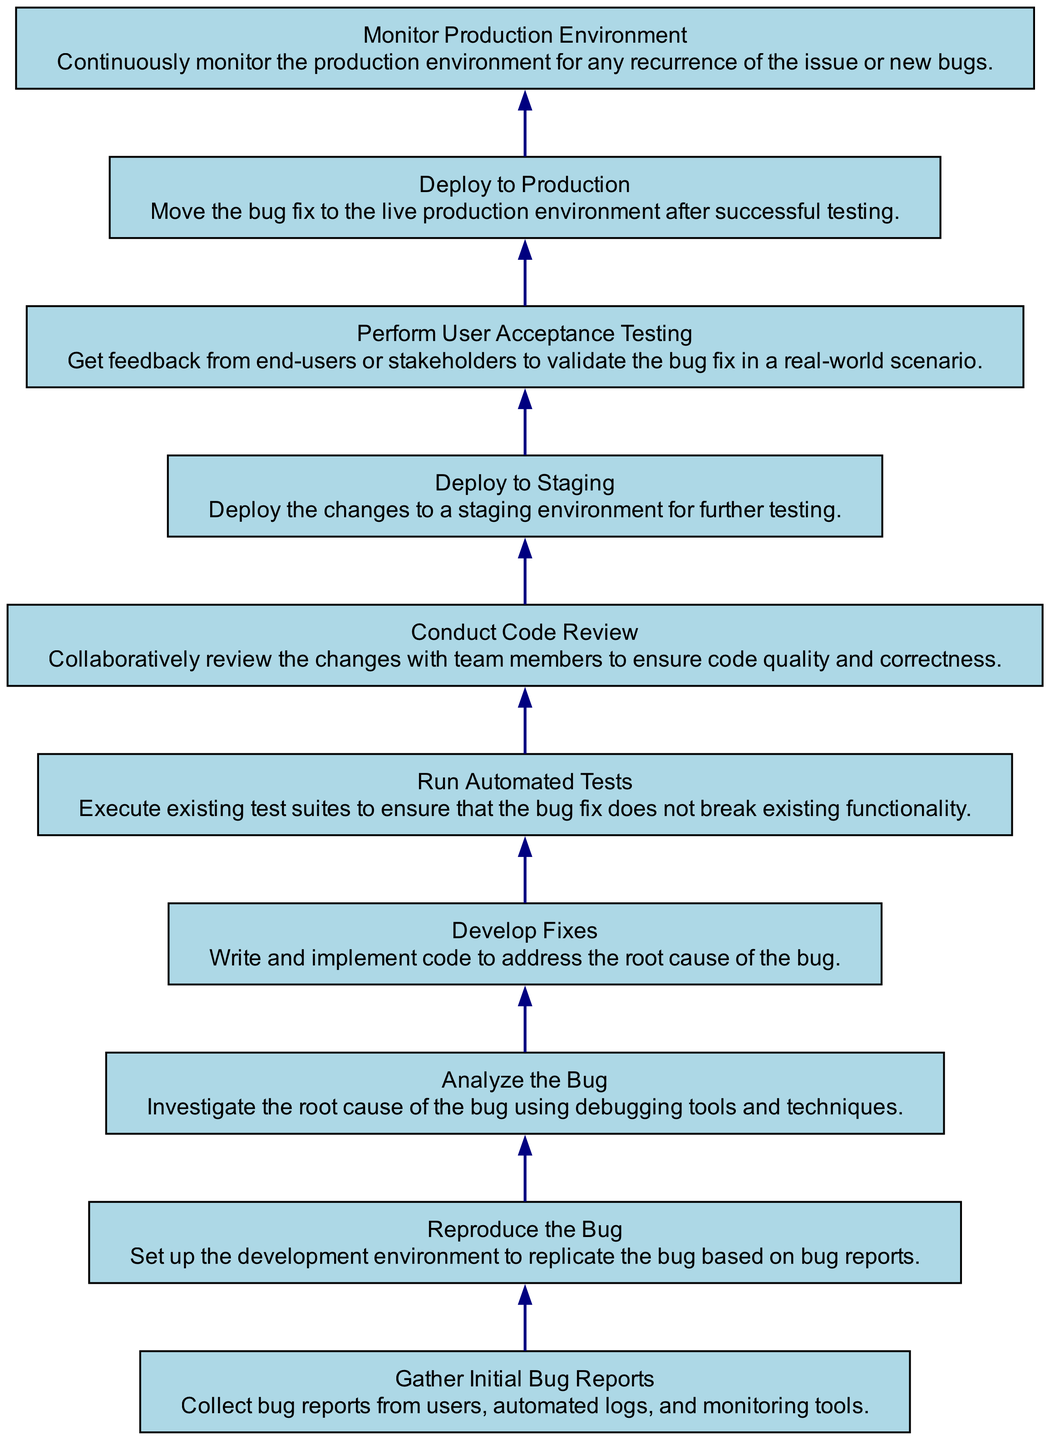What is the last step in the debugging process? The last step in the diagram is "Monitor Production Environment," which indicates the focus on continuous surveillance after deploying the bug fix to ensure no new issues arise.
Answer: Monitor Production Environment What comes before "Deploy to Production"? "Perform User Acceptance Testing" is the step that precedes "Deploy to Production," denoting the importance of validating fixes with stakeholders before going live.
Answer: Perform User Acceptance Testing How many total steps are there in the debugging process? Counting all the unique nodes in the diagram yields ten steps, indicating a structured approach to handle software bugs properly.
Answer: 10 Which step analyzes the bug? The step that involves analyzing the bug is "Analyze the Bug," which focuses on understanding the root cause through debugging tools.
Answer: Analyze the Bug What is the predecessor of "Run Automated Tests"? The predecessor of "Run Automated Tests" is "Develop Fixes," suggesting that tests are run after creating solutions to ensure the integrity of the fixes.
Answer: Develop Fixes Which step is immediately after "Conduct Code Review"? The step immediately after "Conduct Code Review" is "Deploy to Staging," demonstrating a progression from review to staging before live deployment.
Answer: Deploy to Staging What is the purpose of "Gather Initial Bug Reports"? This step involves collecting information on bugs which serves as the foundation for the debugging process, making it essential for subsequent actions.
Answer: Collect bug reports What step validates the bug fix in a real-world scenario? The step that focuses on validating the bug fix in a real-world scenario is "Perform User Acceptance Testing," which emphasizes the importance of user feedback.
Answer: Perform User Acceptance Testing How many steps are there after "Develop Fixes"? There are three steps following "Develop Fixes": "Run Automated Tests," "Conduct Code Review," and "Deploy to Staging," indicating a thorough testing and review process before production.
Answer: 3 